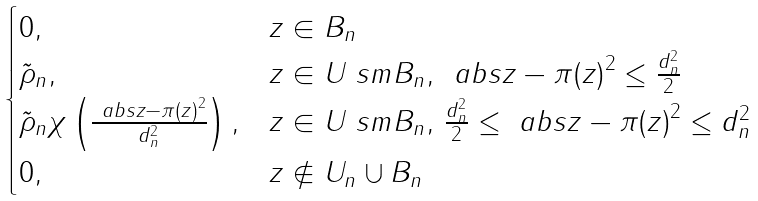<formula> <loc_0><loc_0><loc_500><loc_500>\begin{cases} 0 , & z \in B _ { n } \\ \tilde { \rho } _ { n } , & z \in U \ s m B _ { n } , \, \ a b s { z - \pi ( z ) } ^ { 2 } \leq \frac { d _ { n } ^ { 2 } } { 2 } \\ \tilde { \rho } _ { n } \chi \left ( \frac { \ a b s { z - \pi ( z ) } ^ { 2 } } { d _ { n } ^ { 2 } } \right ) , & z \in U \ s m B _ { n } , \, \frac { d _ { n } ^ { 2 } } { 2 } \leq \ a b s { z - \pi ( z ) } ^ { 2 } \leq d _ { n } ^ { 2 } \\ 0 , & z \not \in U _ { n } \cup B _ { n } \end{cases}</formula> 